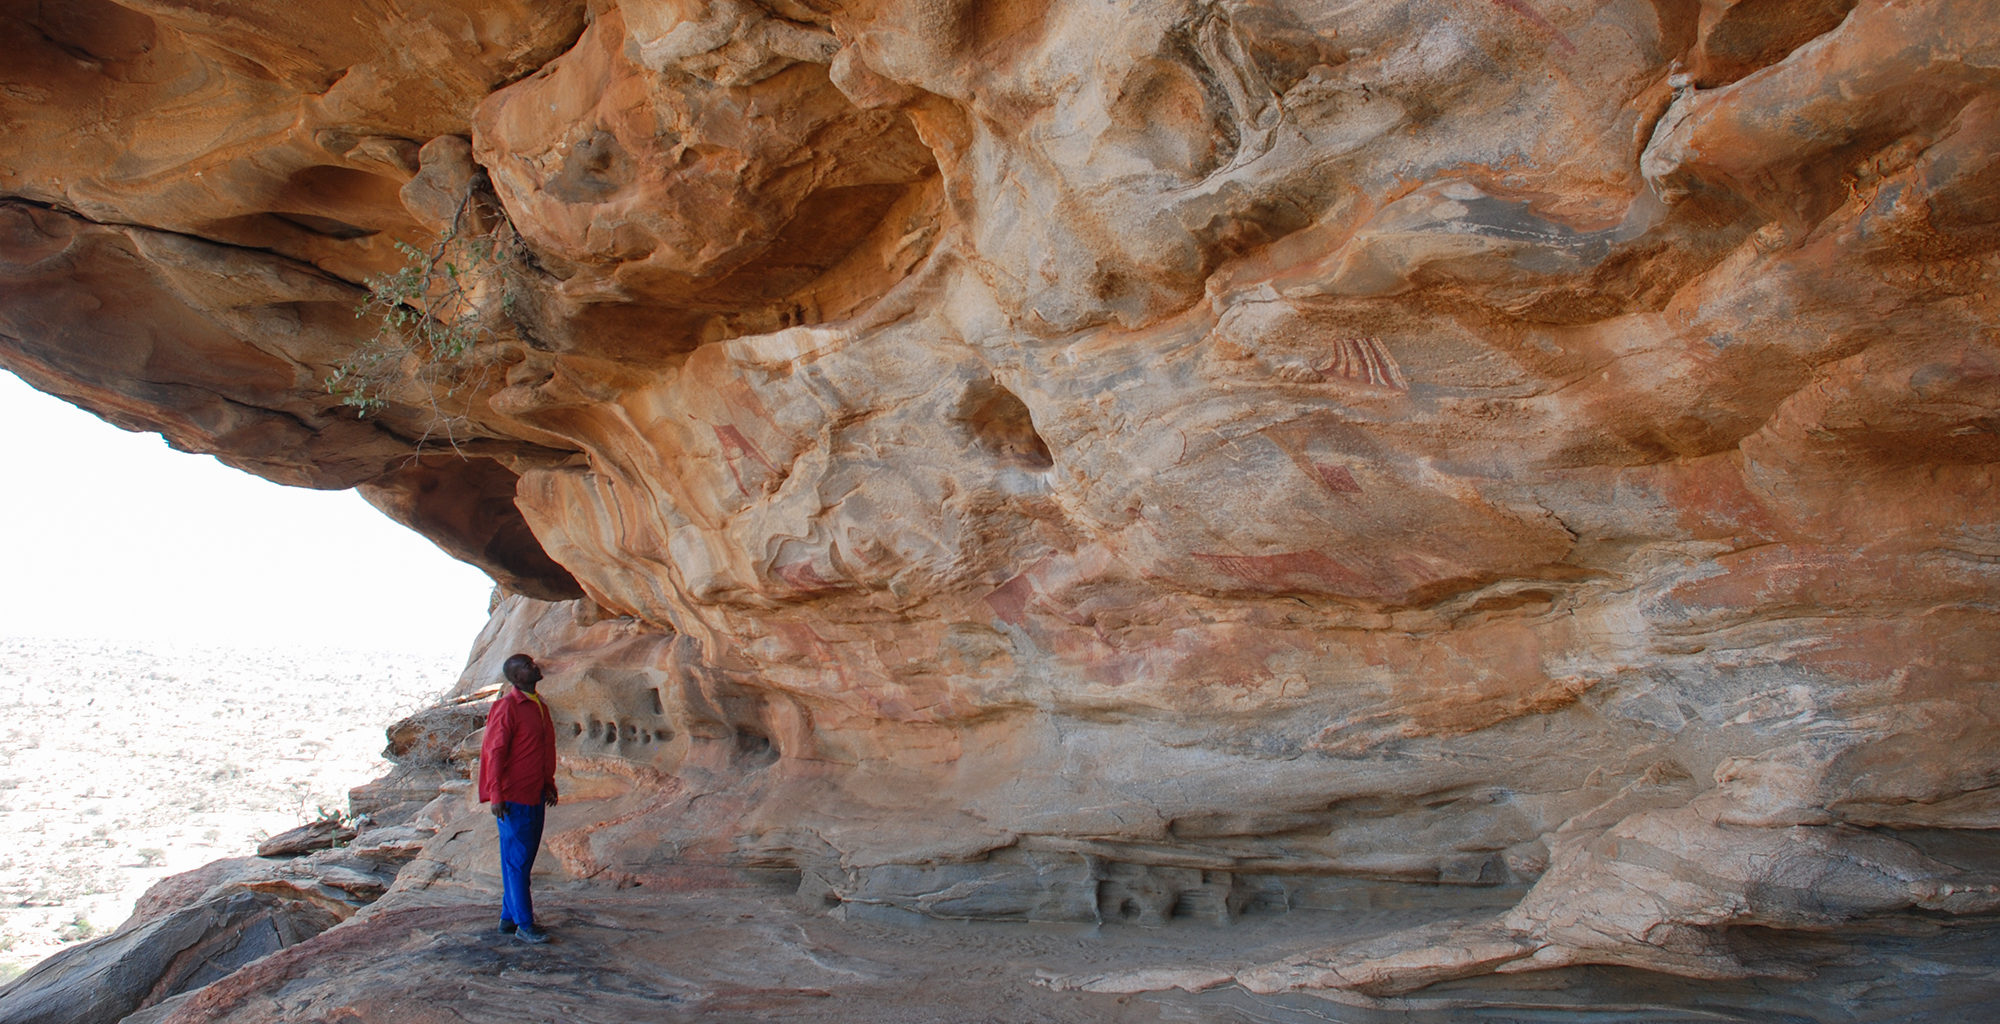If the rocks in this image could speak, what stories do you think they would tell? If the rocks could speak, they would tell tales of ancient civilizations that once thrived in this harsh, beautiful landscape. They would recount the daily lives, rituals, and aspirations of the people who once sought shelter and expression within these caves. These stories would be filled with adventures of survival, artistic endeavors, and spiritual reverence, offering a glimpse into a world long gone but immortalized in the enduring rock art that still captures the imagination of modern observers. 